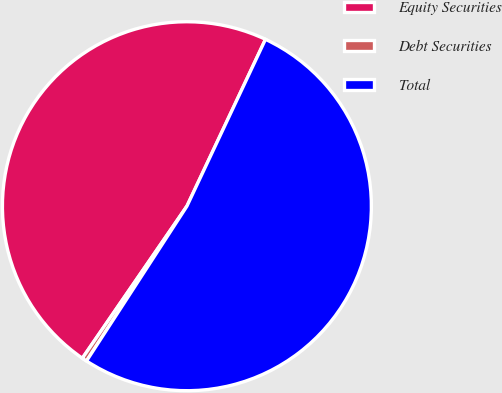Convert chart to OTSL. <chart><loc_0><loc_0><loc_500><loc_500><pie_chart><fcel>Equity Securities<fcel>Debt Securities<fcel>Total<nl><fcel>47.42%<fcel>0.43%<fcel>52.16%<nl></chart> 